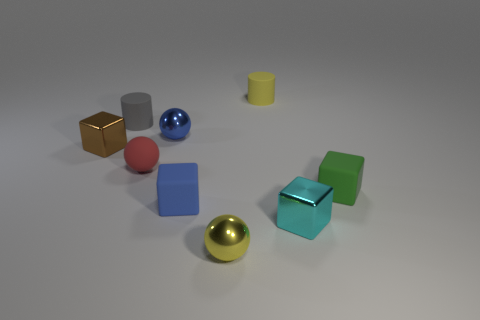Is the shape of the blue object that is behind the matte sphere the same as  the small brown object?
Your answer should be compact. No. What is the small gray cylinder made of?
Offer a very short reply. Rubber. There is a brown thing that is the same size as the yellow rubber object; what shape is it?
Your response must be concise. Cube. Is there a small matte cylinder of the same color as the rubber sphere?
Provide a succinct answer. No. Does the matte sphere have the same color as the small matte thing in front of the small green thing?
Your answer should be compact. No. There is a metal ball that is in front of the metal cube that is left of the yellow rubber object; what is its color?
Your answer should be compact. Yellow. Are there any tiny gray rubber cylinders that are in front of the cyan shiny cube that is in front of the metallic thing on the left side of the small gray thing?
Your response must be concise. No. The ball that is made of the same material as the tiny blue block is what color?
Your answer should be compact. Red. What number of tiny green objects are made of the same material as the small blue block?
Provide a succinct answer. 1. Is the brown object made of the same material as the tiny object in front of the tiny cyan metallic object?
Give a very brief answer. Yes. 